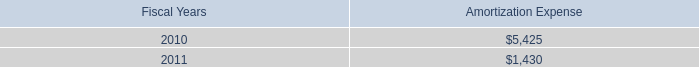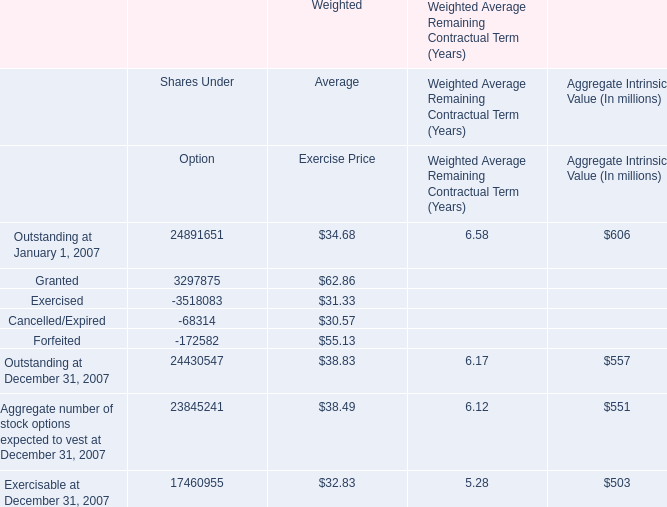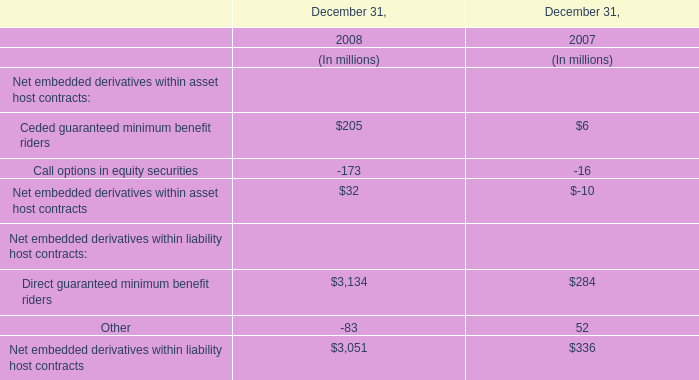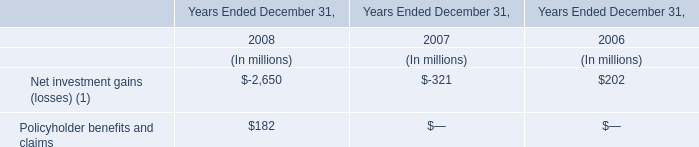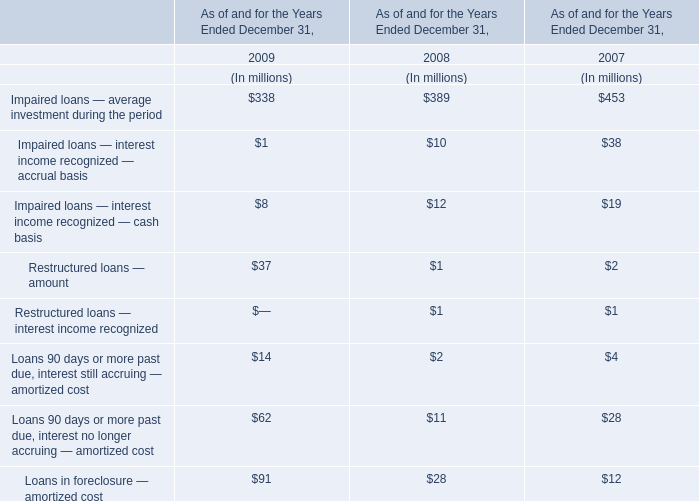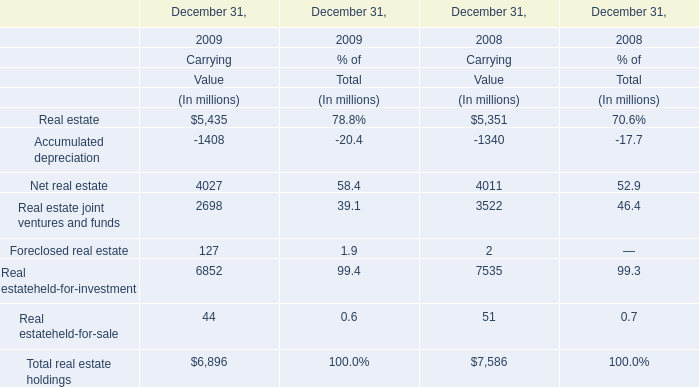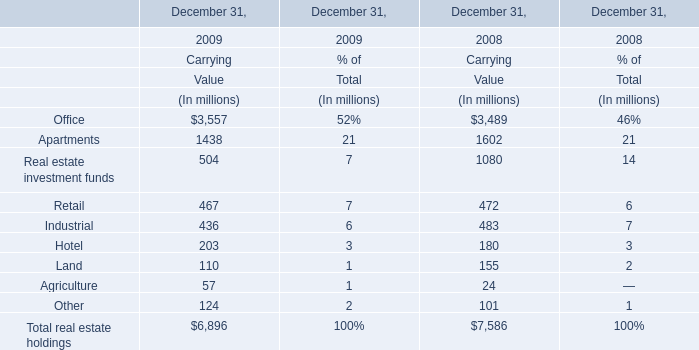What is the growing rate of Restructured loans — amount in the years with the least Impaired loans — average investment during the period? 
Computations: ((37 - 1) / 37)
Answer: 0.97297. 